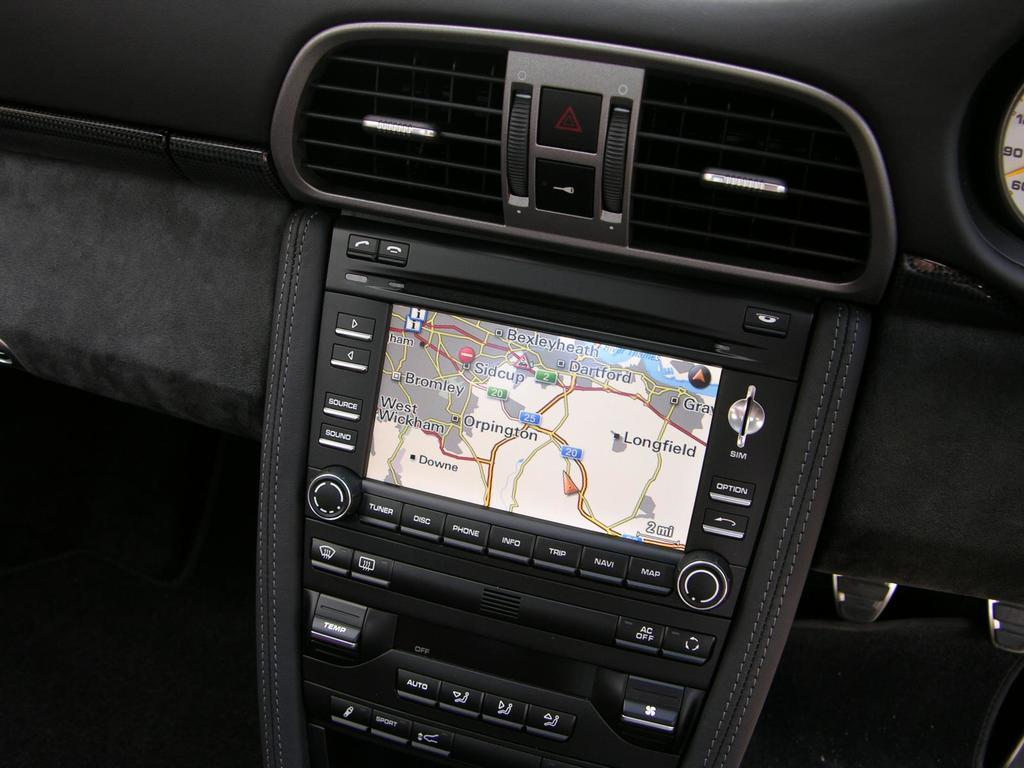Please provide a concise description of this image. In this image there is a dash board, on that dash board there is a ac ventilation and screen with keys. 